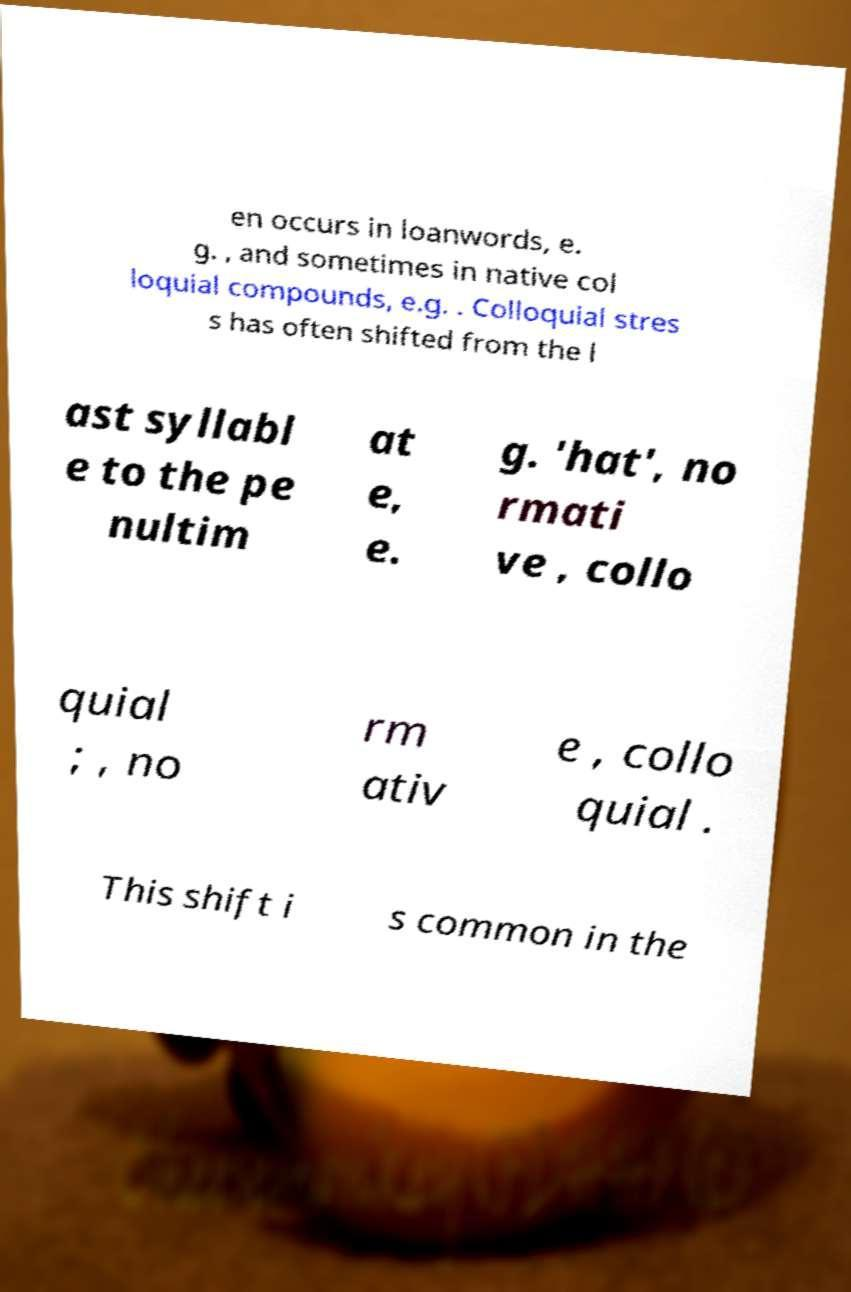There's text embedded in this image that I need extracted. Can you transcribe it verbatim? en occurs in loanwords, e. g. , and sometimes in native col loquial compounds, e.g. . Colloquial stres s has often shifted from the l ast syllabl e to the pe nultim at e, e. g. 'hat', no rmati ve , collo quial ; , no rm ativ e , collo quial . This shift i s common in the 